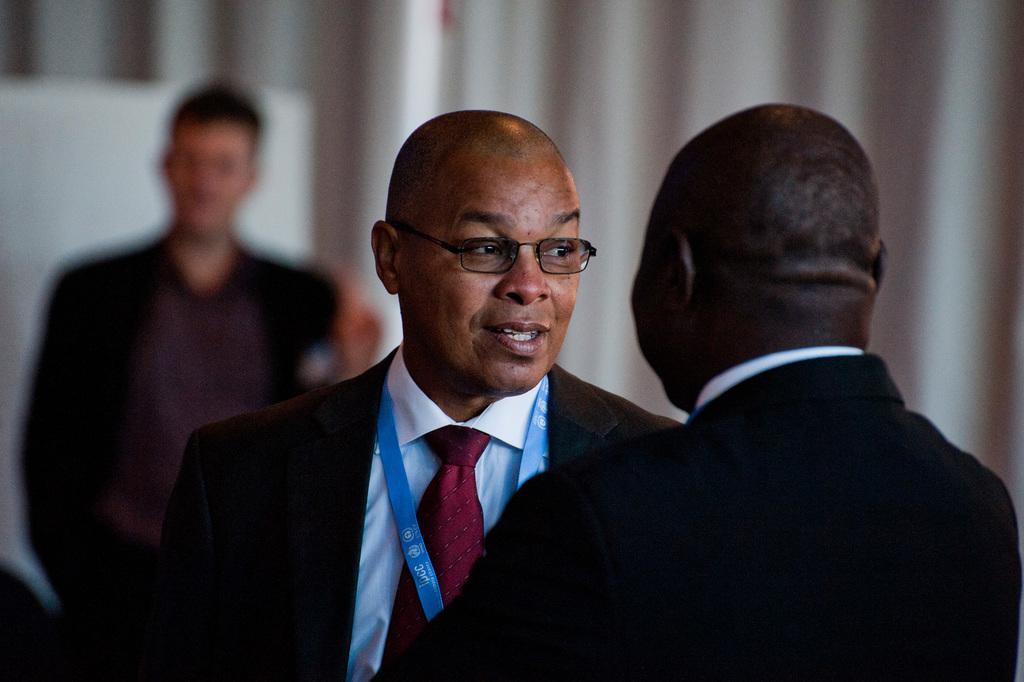Describe this image in one or two sentences. In the image in the center, we can see two persons are standing and smiling. In the background there is a board, curtain and one person standing. 